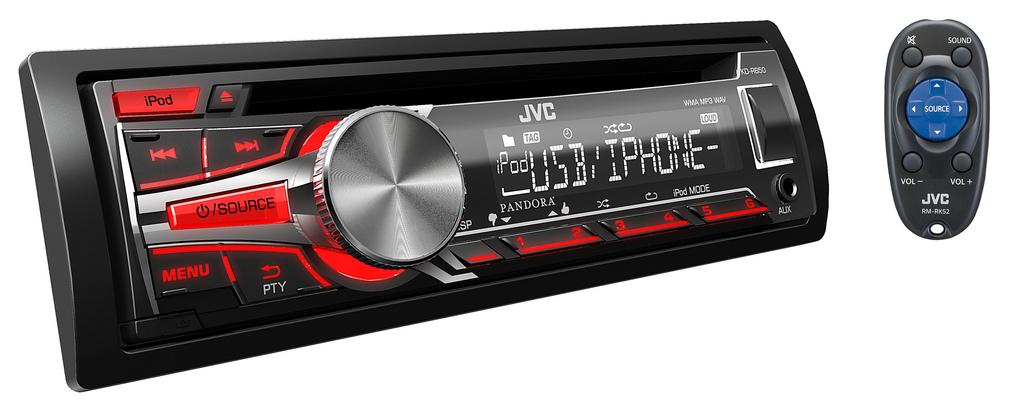<image>
Share a concise interpretation of the image provided. The face of a car radio made by the company JVC 